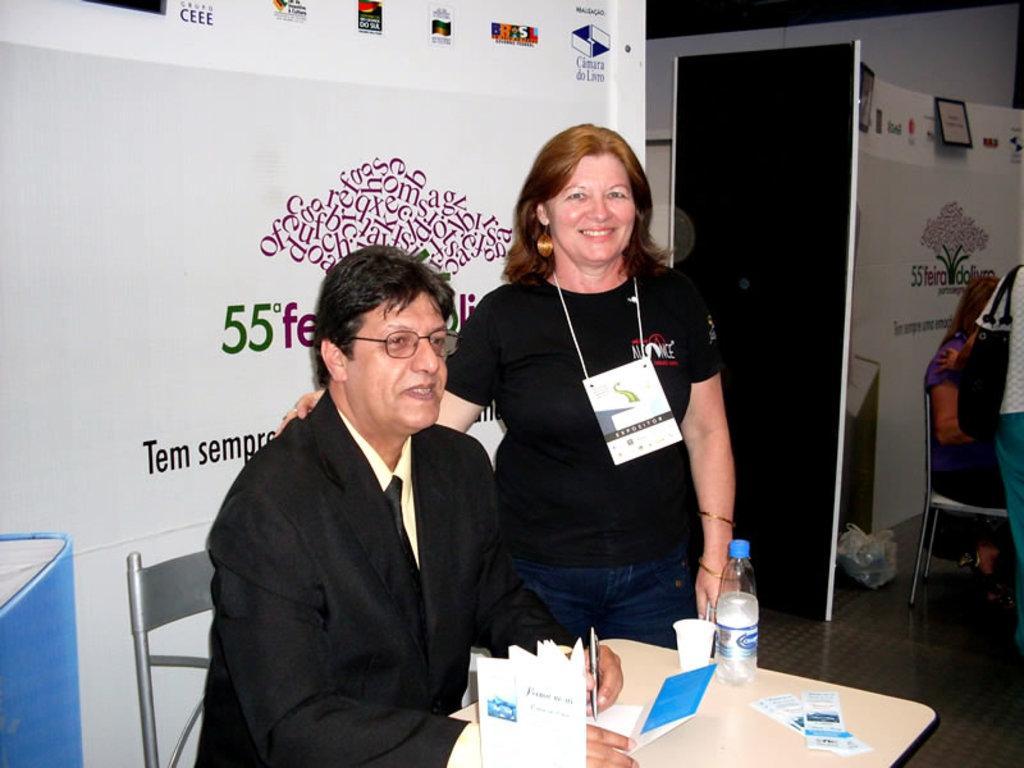In one or two sentences, can you explain what this image depicts? There is a man in black dress wearing spectacle is sitting on a chair. A lady is standing wearing a tag near to him. In front of him there is a table. On the table there is bottle, glass, and book. In the background there is a banner. 